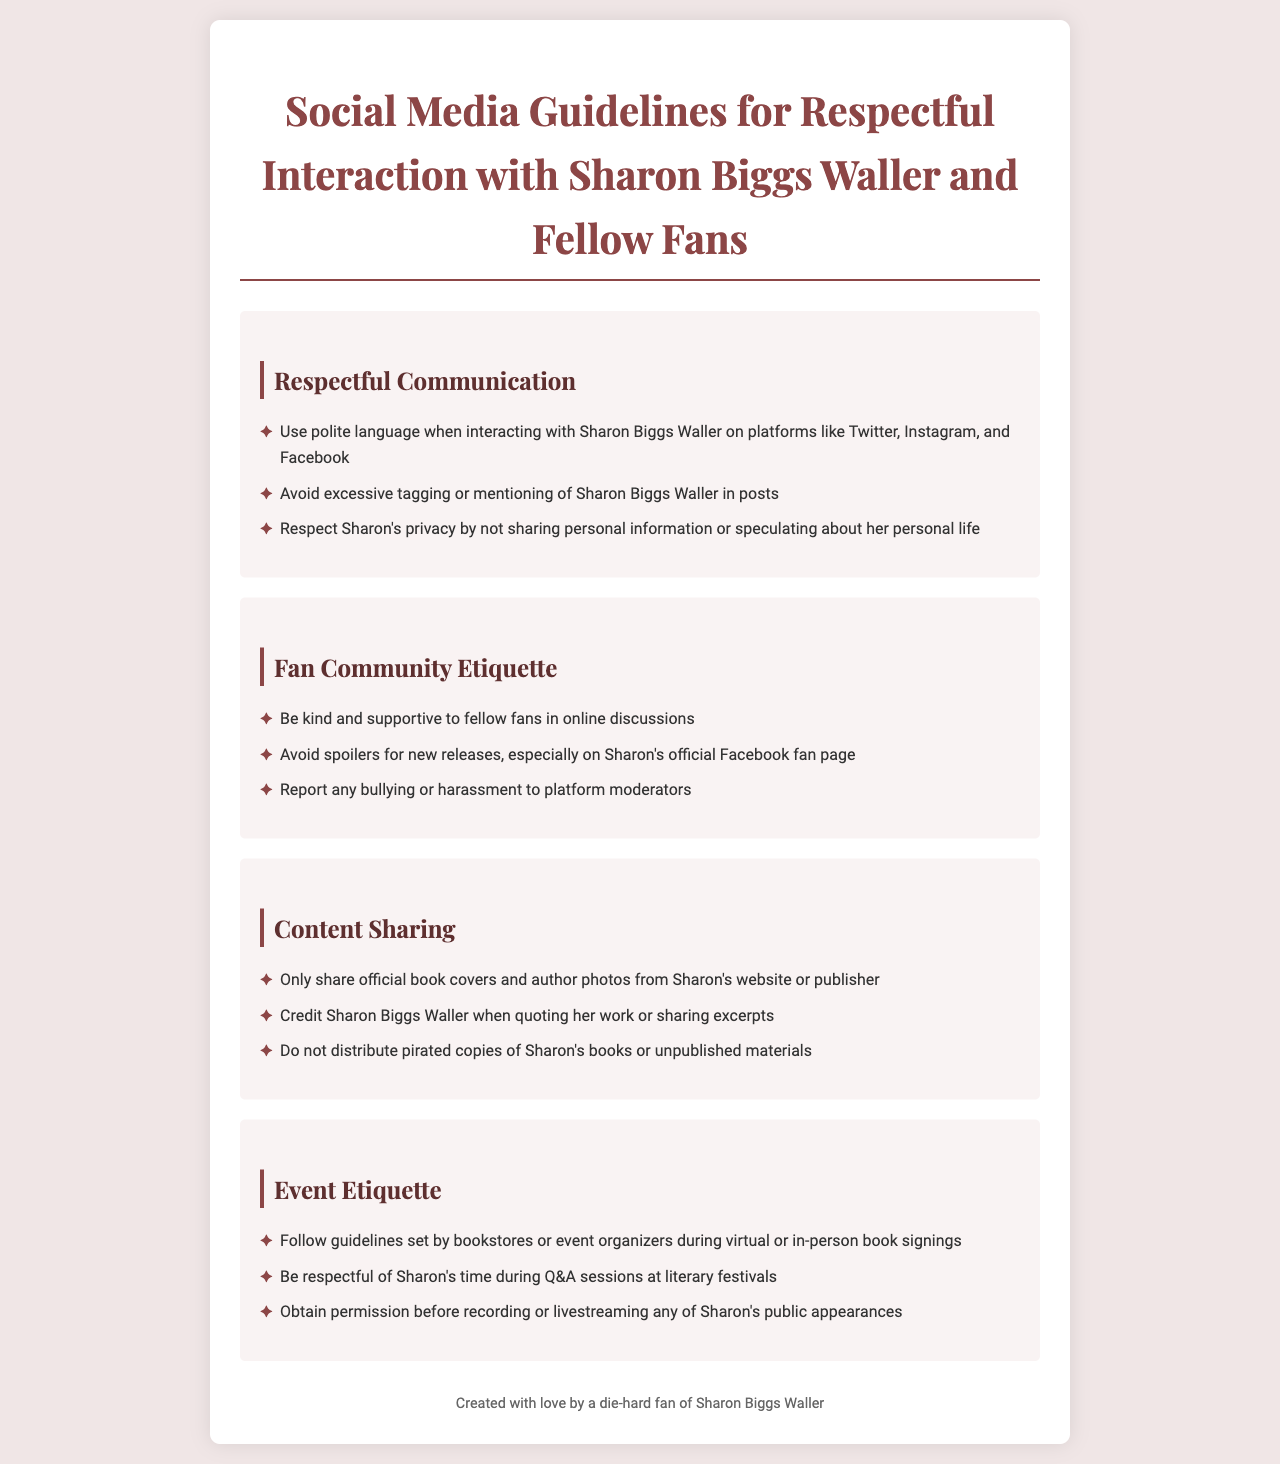What is the title of the document? The title of the document is given at the top and indicates the main subject, which is the social media guidelines.
Answer: Social Media Guidelines for Respectful Interaction with Sharon Biggs Waller and Fellow Fans How many sections are there in the document? The document contains multiple sections, which help to organize the guidelines into clear categories.
Answer: Four What should fans avoid when communicating with Sharon Biggs Waller? The guidelines specify certain behaviors that should be avoided during interactions with Sharon Biggs Waller to maintain respect.
Answer: Excessive tagging What is one of the etiquette rules for the fan community? The document lists behavior expectations for fans when interacting with one another to foster a positive environment.
Answer: Be kind and supportive What must fans do before recording Sharon's public appearances? The document provides specific actions fans should take regarding public recordings during events involving Sharon.
Answer: Obtain permission Where should fans share official book covers? The guidelines specify where fans can find and share certain content related to Sharon Biggs Waller.
Answer: Sharon's website or publisher What is required when quoting Sharon Biggs Waller's work? The document includes a requirement regarding the use of Sharon's written work in fan interactions or content sharing.
Answer: Credit Sharon Biggs Waller What should fans report in online discussions? The guidelines outline the behavior that must be reported to maintain a respectful fan community.
Answer: Bullying or harassment 